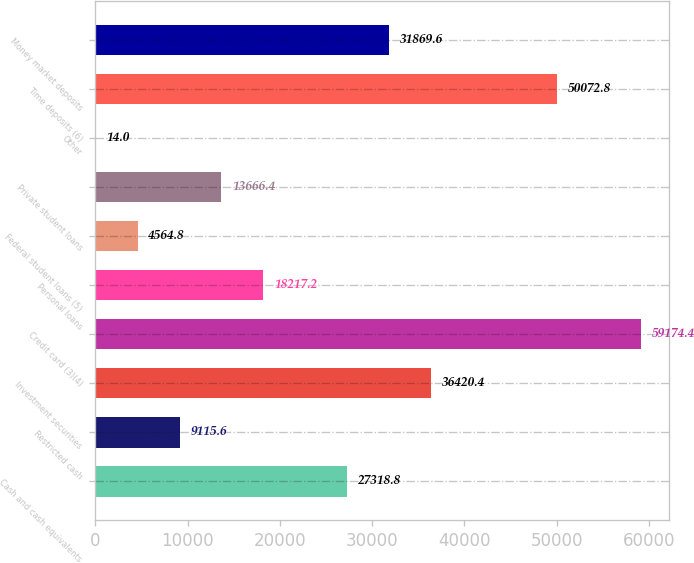<chart> <loc_0><loc_0><loc_500><loc_500><bar_chart><fcel>Cash and cash equivalents<fcel>Restricted cash<fcel>Investment securities<fcel>Credit card (3)(4)<fcel>Personal loans<fcel>Federal student loans (5)<fcel>Private student loans<fcel>Other<fcel>Time deposits (6)<fcel>Money market deposits<nl><fcel>27318.8<fcel>9115.6<fcel>36420.4<fcel>59174.4<fcel>18217.2<fcel>4564.8<fcel>13666.4<fcel>14<fcel>50072.8<fcel>31869.6<nl></chart> 